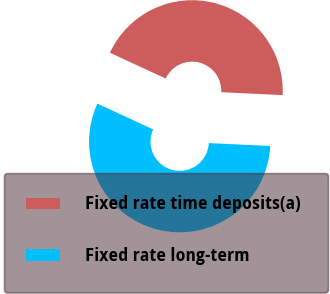Convert chart to OTSL. <chart><loc_0><loc_0><loc_500><loc_500><pie_chart><fcel>Fixed rate time deposits(a)<fcel>Fixed rate long-term<nl><fcel>43.85%<fcel>56.15%<nl></chart> 